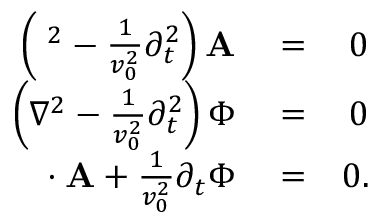Convert formula to latex. <formula><loc_0><loc_0><loc_500><loc_500>\begin{array} { r l r } { \left ( { \nabla } ^ { 2 } - \frac { 1 } { v _ { 0 } ^ { 2 } } \partial _ { t } ^ { 2 } \right ) { A } } & = } & { 0 } \\ { \left ( \nabla ^ { 2 } - \frac { 1 } { v _ { 0 } ^ { 2 } } \partial _ { t } ^ { 2 } \right ) \Phi } & = } & { 0 } \\ { { \nabla } \cdot { A } + \frac { 1 } { v _ { 0 } ^ { 2 } } \partial _ { t } \Phi } & = } & { 0 . } \end{array}</formula> 